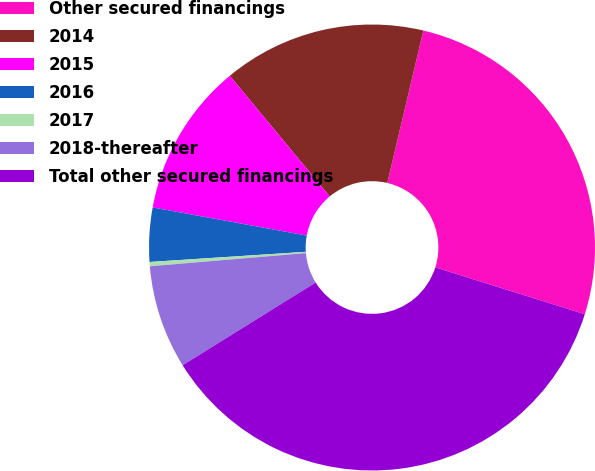<chart> <loc_0><loc_0><loc_500><loc_500><pie_chart><fcel>Other secured financings<fcel>2014<fcel>2015<fcel>2016<fcel>2017<fcel>2018-thereafter<fcel>Total other secured financings<nl><fcel>26.14%<fcel>14.71%<fcel>11.11%<fcel>3.91%<fcel>0.31%<fcel>7.51%<fcel>36.31%<nl></chart> 